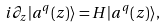<formula> <loc_0><loc_0><loc_500><loc_500>i \partial _ { z } | a ^ { q } ( z ) \rangle = { H } | a ^ { q } ( z ) \rangle ,</formula> 